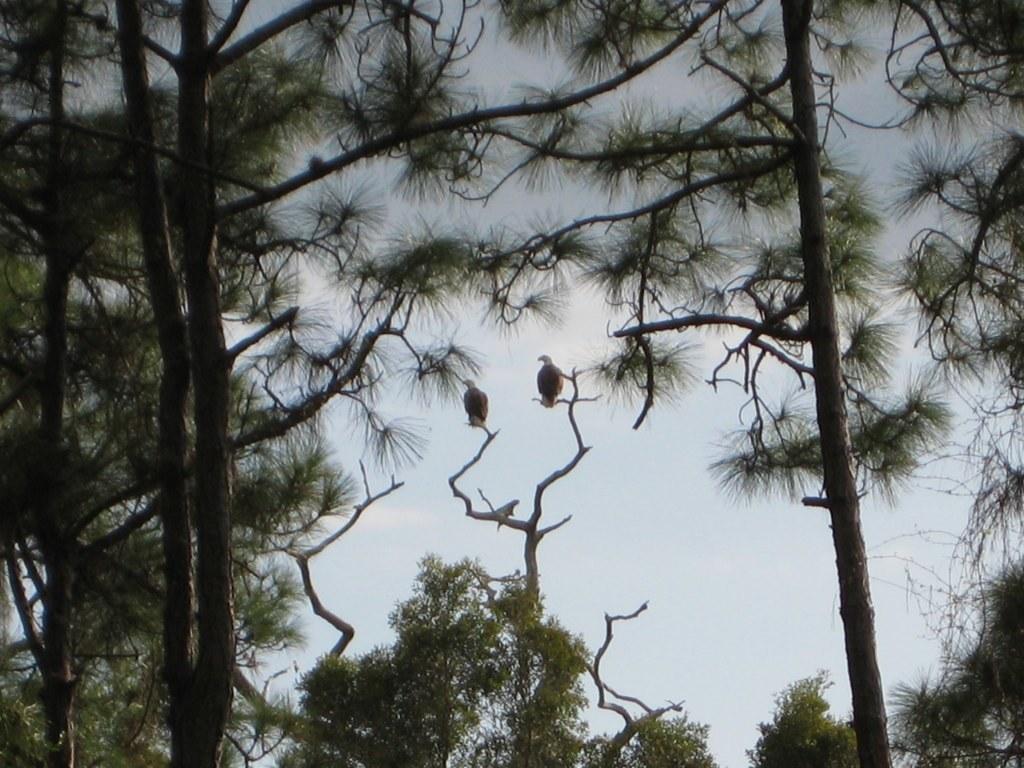Describe this image in one or two sentences. In the foreground of this image, there are trees and two birds on a stem. In the background, there is the sky. 